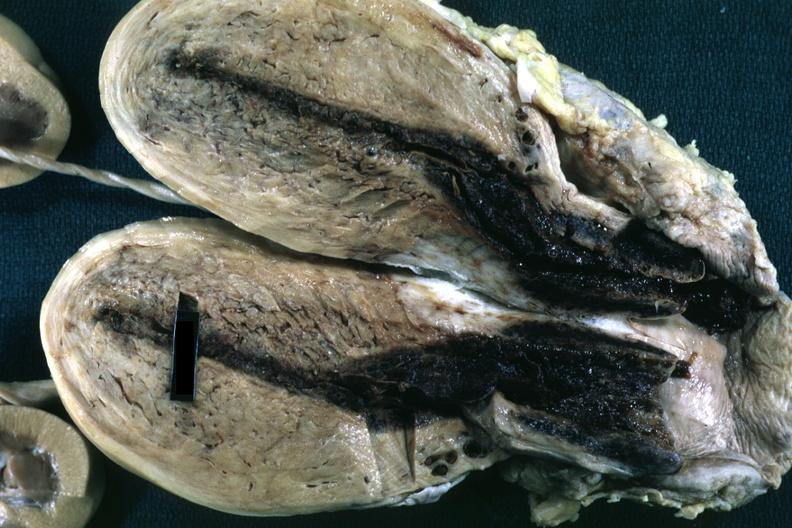how is fixed tissue opened uterus with blood clot in canal and small endometrial cavity?
Answer the question using a single word or phrase. Cervical 